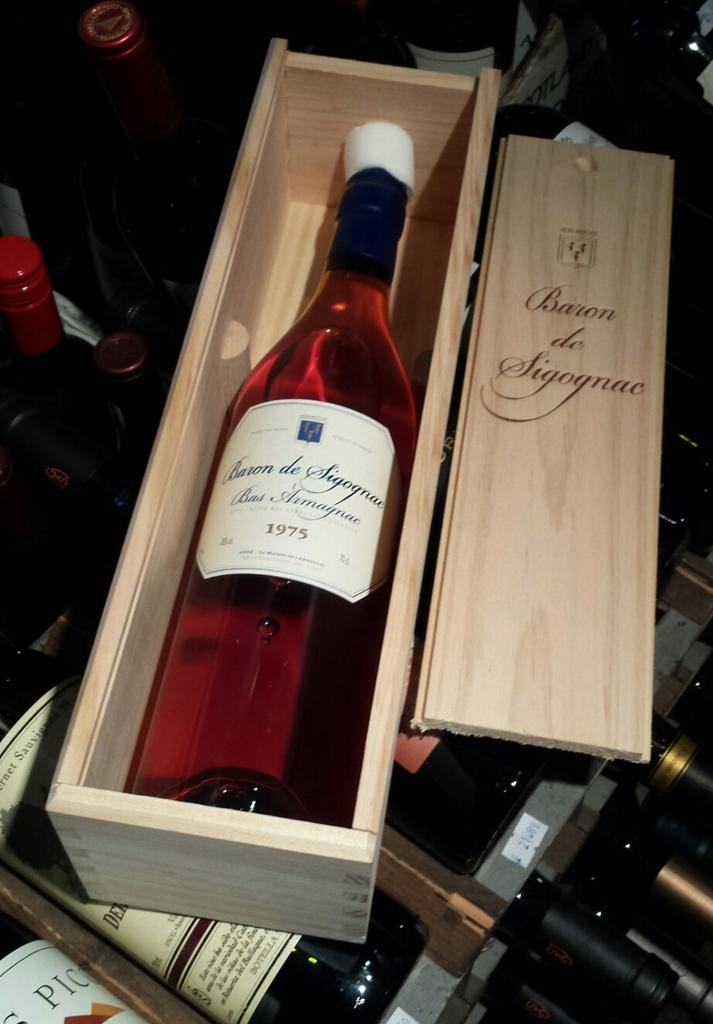<image>
Describe the image concisely. A 1975 bottle of Baron de Sigognac is shown inside its wooden case. 